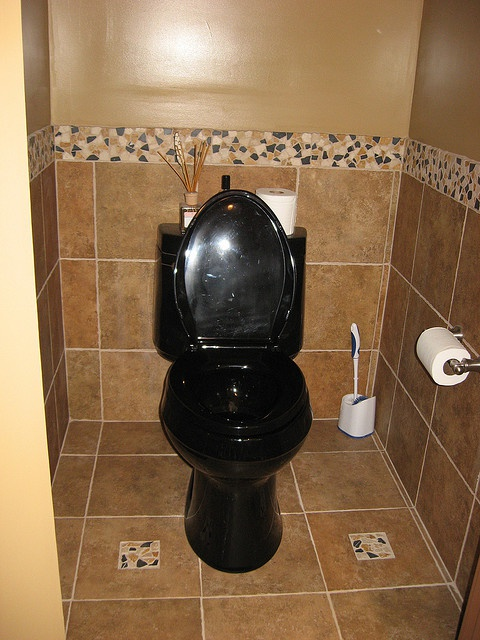Describe the objects in this image and their specific colors. I can see a toilet in tan, black, gray, and maroon tones in this image. 